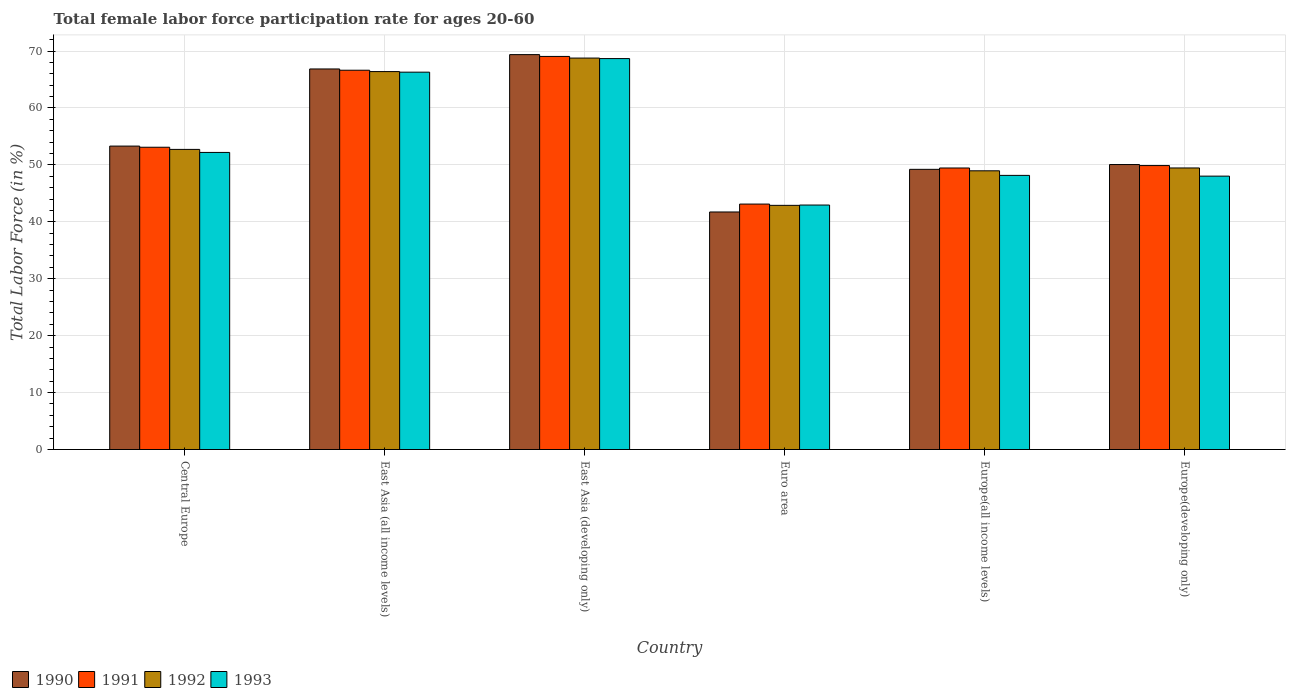How many different coloured bars are there?
Ensure brevity in your answer.  4. How many bars are there on the 2nd tick from the left?
Ensure brevity in your answer.  4. How many bars are there on the 1st tick from the right?
Your answer should be very brief. 4. What is the label of the 6th group of bars from the left?
Provide a short and direct response. Europe(developing only). What is the female labor force participation rate in 1993 in Central Europe?
Your answer should be very brief. 52.19. Across all countries, what is the maximum female labor force participation rate in 1993?
Give a very brief answer. 68.67. Across all countries, what is the minimum female labor force participation rate in 1990?
Give a very brief answer. 41.73. In which country was the female labor force participation rate in 1991 maximum?
Offer a terse response. East Asia (developing only). In which country was the female labor force participation rate in 1993 minimum?
Offer a very short reply. Euro area. What is the total female labor force participation rate in 1990 in the graph?
Ensure brevity in your answer.  330.54. What is the difference between the female labor force participation rate in 1993 in East Asia (all income levels) and that in Europe(all income levels)?
Offer a very short reply. 18.13. What is the difference between the female labor force participation rate in 1990 in East Asia (developing only) and the female labor force participation rate in 1991 in Europe(developing only)?
Your response must be concise. 19.49. What is the average female labor force participation rate in 1991 per country?
Make the answer very short. 55.21. What is the difference between the female labor force participation rate of/in 1992 and female labor force participation rate of/in 1993 in East Asia (all income levels)?
Make the answer very short. 0.1. What is the ratio of the female labor force participation rate in 1993 in East Asia (all income levels) to that in East Asia (developing only)?
Keep it short and to the point. 0.97. Is the female labor force participation rate in 1991 in East Asia (all income levels) less than that in Europe(developing only)?
Your answer should be very brief. No. What is the difference between the highest and the second highest female labor force participation rate in 1991?
Your response must be concise. 13.53. What is the difference between the highest and the lowest female labor force participation rate in 1991?
Make the answer very short. 25.94. Is the sum of the female labor force participation rate in 1992 in East Asia (developing only) and Europe(developing only) greater than the maximum female labor force participation rate in 1993 across all countries?
Your response must be concise. Yes. Is it the case that in every country, the sum of the female labor force participation rate in 1990 and female labor force participation rate in 1991 is greater than the sum of female labor force participation rate in 1992 and female labor force participation rate in 1993?
Offer a terse response. No. How many bars are there?
Provide a succinct answer. 24. Are the values on the major ticks of Y-axis written in scientific E-notation?
Offer a terse response. No. Does the graph contain any zero values?
Your answer should be compact. No. Does the graph contain grids?
Provide a succinct answer. Yes. Where does the legend appear in the graph?
Give a very brief answer. Bottom left. How are the legend labels stacked?
Your response must be concise. Horizontal. What is the title of the graph?
Offer a terse response. Total female labor force participation rate for ages 20-60. What is the label or title of the Y-axis?
Give a very brief answer. Total Labor Force (in %). What is the Total Labor Force (in %) of 1990 in Central Europe?
Provide a succinct answer. 53.31. What is the Total Labor Force (in %) in 1991 in Central Europe?
Give a very brief answer. 53.1. What is the Total Labor Force (in %) of 1992 in Central Europe?
Offer a terse response. 52.72. What is the Total Labor Force (in %) of 1993 in Central Europe?
Offer a very short reply. 52.19. What is the Total Labor Force (in %) in 1990 in East Asia (all income levels)?
Your answer should be compact. 66.85. What is the Total Labor Force (in %) in 1991 in East Asia (all income levels)?
Your answer should be compact. 66.63. What is the Total Labor Force (in %) of 1992 in East Asia (all income levels)?
Ensure brevity in your answer.  66.39. What is the Total Labor Force (in %) in 1993 in East Asia (all income levels)?
Your answer should be compact. 66.29. What is the Total Labor Force (in %) in 1990 in East Asia (developing only)?
Make the answer very short. 69.37. What is the Total Labor Force (in %) of 1991 in East Asia (developing only)?
Offer a terse response. 69.06. What is the Total Labor Force (in %) in 1992 in East Asia (developing only)?
Give a very brief answer. 68.77. What is the Total Labor Force (in %) in 1993 in East Asia (developing only)?
Offer a very short reply. 68.67. What is the Total Labor Force (in %) of 1990 in Euro area?
Give a very brief answer. 41.73. What is the Total Labor Force (in %) of 1991 in Euro area?
Provide a short and direct response. 43.12. What is the Total Labor Force (in %) of 1992 in Euro area?
Ensure brevity in your answer.  42.89. What is the Total Labor Force (in %) in 1993 in Euro area?
Offer a terse response. 42.95. What is the Total Labor Force (in %) in 1990 in Europe(all income levels)?
Provide a succinct answer. 49.22. What is the Total Labor Force (in %) in 1991 in Europe(all income levels)?
Offer a very short reply. 49.46. What is the Total Labor Force (in %) of 1992 in Europe(all income levels)?
Make the answer very short. 48.96. What is the Total Labor Force (in %) in 1993 in Europe(all income levels)?
Offer a very short reply. 48.16. What is the Total Labor Force (in %) in 1990 in Europe(developing only)?
Your response must be concise. 50.06. What is the Total Labor Force (in %) in 1991 in Europe(developing only)?
Provide a short and direct response. 49.88. What is the Total Labor Force (in %) in 1992 in Europe(developing only)?
Ensure brevity in your answer.  49.46. What is the Total Labor Force (in %) in 1993 in Europe(developing only)?
Your answer should be compact. 48.03. Across all countries, what is the maximum Total Labor Force (in %) in 1990?
Keep it short and to the point. 69.37. Across all countries, what is the maximum Total Labor Force (in %) of 1991?
Your answer should be compact. 69.06. Across all countries, what is the maximum Total Labor Force (in %) of 1992?
Provide a short and direct response. 68.77. Across all countries, what is the maximum Total Labor Force (in %) of 1993?
Offer a very short reply. 68.67. Across all countries, what is the minimum Total Labor Force (in %) of 1990?
Your answer should be compact. 41.73. Across all countries, what is the minimum Total Labor Force (in %) of 1991?
Your answer should be compact. 43.12. Across all countries, what is the minimum Total Labor Force (in %) in 1992?
Offer a terse response. 42.89. Across all countries, what is the minimum Total Labor Force (in %) of 1993?
Keep it short and to the point. 42.95. What is the total Total Labor Force (in %) of 1990 in the graph?
Keep it short and to the point. 330.54. What is the total Total Labor Force (in %) of 1991 in the graph?
Make the answer very short. 331.24. What is the total Total Labor Force (in %) in 1992 in the graph?
Keep it short and to the point. 329.2. What is the total Total Labor Force (in %) of 1993 in the graph?
Make the answer very short. 326.28. What is the difference between the Total Labor Force (in %) in 1990 in Central Europe and that in East Asia (all income levels)?
Offer a terse response. -13.55. What is the difference between the Total Labor Force (in %) in 1991 in Central Europe and that in East Asia (all income levels)?
Give a very brief answer. -13.53. What is the difference between the Total Labor Force (in %) of 1992 in Central Europe and that in East Asia (all income levels)?
Provide a succinct answer. -13.67. What is the difference between the Total Labor Force (in %) in 1993 in Central Europe and that in East Asia (all income levels)?
Give a very brief answer. -14.1. What is the difference between the Total Labor Force (in %) of 1990 in Central Europe and that in East Asia (developing only)?
Give a very brief answer. -16.07. What is the difference between the Total Labor Force (in %) of 1991 in Central Europe and that in East Asia (developing only)?
Offer a very short reply. -15.95. What is the difference between the Total Labor Force (in %) of 1992 in Central Europe and that in East Asia (developing only)?
Keep it short and to the point. -16.04. What is the difference between the Total Labor Force (in %) in 1993 in Central Europe and that in East Asia (developing only)?
Your answer should be very brief. -16.49. What is the difference between the Total Labor Force (in %) in 1990 in Central Europe and that in Euro area?
Offer a terse response. 11.58. What is the difference between the Total Labor Force (in %) in 1991 in Central Europe and that in Euro area?
Make the answer very short. 9.98. What is the difference between the Total Labor Force (in %) in 1992 in Central Europe and that in Euro area?
Your answer should be compact. 9.83. What is the difference between the Total Labor Force (in %) in 1993 in Central Europe and that in Euro area?
Your answer should be compact. 9.24. What is the difference between the Total Labor Force (in %) of 1990 in Central Europe and that in Europe(all income levels)?
Offer a terse response. 4.08. What is the difference between the Total Labor Force (in %) of 1991 in Central Europe and that in Europe(all income levels)?
Provide a short and direct response. 3.64. What is the difference between the Total Labor Force (in %) of 1992 in Central Europe and that in Europe(all income levels)?
Your response must be concise. 3.76. What is the difference between the Total Labor Force (in %) of 1993 in Central Europe and that in Europe(all income levels)?
Your response must be concise. 4.03. What is the difference between the Total Labor Force (in %) of 1990 in Central Europe and that in Europe(developing only)?
Provide a succinct answer. 3.24. What is the difference between the Total Labor Force (in %) of 1991 in Central Europe and that in Europe(developing only)?
Your response must be concise. 3.22. What is the difference between the Total Labor Force (in %) in 1992 in Central Europe and that in Europe(developing only)?
Your answer should be compact. 3.26. What is the difference between the Total Labor Force (in %) in 1993 in Central Europe and that in Europe(developing only)?
Give a very brief answer. 4.16. What is the difference between the Total Labor Force (in %) of 1990 in East Asia (all income levels) and that in East Asia (developing only)?
Offer a very short reply. -2.52. What is the difference between the Total Labor Force (in %) in 1991 in East Asia (all income levels) and that in East Asia (developing only)?
Provide a short and direct response. -2.43. What is the difference between the Total Labor Force (in %) of 1992 in East Asia (all income levels) and that in East Asia (developing only)?
Your answer should be very brief. -2.37. What is the difference between the Total Labor Force (in %) of 1993 in East Asia (all income levels) and that in East Asia (developing only)?
Offer a terse response. -2.38. What is the difference between the Total Labor Force (in %) in 1990 in East Asia (all income levels) and that in Euro area?
Offer a terse response. 25.12. What is the difference between the Total Labor Force (in %) of 1991 in East Asia (all income levels) and that in Euro area?
Give a very brief answer. 23.51. What is the difference between the Total Labor Force (in %) in 1992 in East Asia (all income levels) and that in Euro area?
Give a very brief answer. 23.5. What is the difference between the Total Labor Force (in %) of 1993 in East Asia (all income levels) and that in Euro area?
Keep it short and to the point. 23.34. What is the difference between the Total Labor Force (in %) in 1990 in East Asia (all income levels) and that in Europe(all income levels)?
Offer a terse response. 17.63. What is the difference between the Total Labor Force (in %) of 1991 in East Asia (all income levels) and that in Europe(all income levels)?
Your response must be concise. 17.17. What is the difference between the Total Labor Force (in %) of 1992 in East Asia (all income levels) and that in Europe(all income levels)?
Your answer should be very brief. 17.43. What is the difference between the Total Labor Force (in %) of 1993 in East Asia (all income levels) and that in Europe(all income levels)?
Your answer should be very brief. 18.13. What is the difference between the Total Labor Force (in %) in 1990 in East Asia (all income levels) and that in Europe(developing only)?
Provide a short and direct response. 16.79. What is the difference between the Total Labor Force (in %) of 1991 in East Asia (all income levels) and that in Europe(developing only)?
Your answer should be compact. 16.75. What is the difference between the Total Labor Force (in %) of 1992 in East Asia (all income levels) and that in Europe(developing only)?
Make the answer very short. 16.93. What is the difference between the Total Labor Force (in %) of 1993 in East Asia (all income levels) and that in Europe(developing only)?
Your answer should be very brief. 18.26. What is the difference between the Total Labor Force (in %) in 1990 in East Asia (developing only) and that in Euro area?
Give a very brief answer. 27.64. What is the difference between the Total Labor Force (in %) of 1991 in East Asia (developing only) and that in Euro area?
Offer a terse response. 25.94. What is the difference between the Total Labor Force (in %) of 1992 in East Asia (developing only) and that in Euro area?
Your answer should be compact. 25.87. What is the difference between the Total Labor Force (in %) in 1993 in East Asia (developing only) and that in Euro area?
Keep it short and to the point. 25.73. What is the difference between the Total Labor Force (in %) of 1990 in East Asia (developing only) and that in Europe(all income levels)?
Offer a terse response. 20.15. What is the difference between the Total Labor Force (in %) in 1991 in East Asia (developing only) and that in Europe(all income levels)?
Provide a succinct answer. 19.6. What is the difference between the Total Labor Force (in %) of 1992 in East Asia (developing only) and that in Europe(all income levels)?
Your response must be concise. 19.81. What is the difference between the Total Labor Force (in %) of 1993 in East Asia (developing only) and that in Europe(all income levels)?
Your answer should be very brief. 20.52. What is the difference between the Total Labor Force (in %) in 1990 in East Asia (developing only) and that in Europe(developing only)?
Your answer should be compact. 19.31. What is the difference between the Total Labor Force (in %) of 1991 in East Asia (developing only) and that in Europe(developing only)?
Your answer should be compact. 19.17. What is the difference between the Total Labor Force (in %) of 1992 in East Asia (developing only) and that in Europe(developing only)?
Keep it short and to the point. 19.3. What is the difference between the Total Labor Force (in %) in 1993 in East Asia (developing only) and that in Europe(developing only)?
Your response must be concise. 20.65. What is the difference between the Total Labor Force (in %) in 1990 in Euro area and that in Europe(all income levels)?
Your answer should be very brief. -7.49. What is the difference between the Total Labor Force (in %) of 1991 in Euro area and that in Europe(all income levels)?
Provide a succinct answer. -6.34. What is the difference between the Total Labor Force (in %) in 1992 in Euro area and that in Europe(all income levels)?
Provide a succinct answer. -6.07. What is the difference between the Total Labor Force (in %) of 1993 in Euro area and that in Europe(all income levels)?
Your answer should be compact. -5.21. What is the difference between the Total Labor Force (in %) in 1990 in Euro area and that in Europe(developing only)?
Your answer should be compact. -8.33. What is the difference between the Total Labor Force (in %) of 1991 in Euro area and that in Europe(developing only)?
Keep it short and to the point. -6.76. What is the difference between the Total Labor Force (in %) of 1992 in Euro area and that in Europe(developing only)?
Ensure brevity in your answer.  -6.57. What is the difference between the Total Labor Force (in %) of 1993 in Euro area and that in Europe(developing only)?
Your answer should be very brief. -5.08. What is the difference between the Total Labor Force (in %) of 1990 in Europe(all income levels) and that in Europe(developing only)?
Keep it short and to the point. -0.84. What is the difference between the Total Labor Force (in %) of 1991 in Europe(all income levels) and that in Europe(developing only)?
Provide a succinct answer. -0.43. What is the difference between the Total Labor Force (in %) of 1992 in Europe(all income levels) and that in Europe(developing only)?
Provide a succinct answer. -0.5. What is the difference between the Total Labor Force (in %) of 1993 in Europe(all income levels) and that in Europe(developing only)?
Provide a succinct answer. 0.13. What is the difference between the Total Labor Force (in %) in 1990 in Central Europe and the Total Labor Force (in %) in 1991 in East Asia (all income levels)?
Give a very brief answer. -13.32. What is the difference between the Total Labor Force (in %) in 1990 in Central Europe and the Total Labor Force (in %) in 1992 in East Asia (all income levels)?
Your answer should be very brief. -13.09. What is the difference between the Total Labor Force (in %) in 1990 in Central Europe and the Total Labor Force (in %) in 1993 in East Asia (all income levels)?
Offer a terse response. -12.99. What is the difference between the Total Labor Force (in %) in 1991 in Central Europe and the Total Labor Force (in %) in 1992 in East Asia (all income levels)?
Give a very brief answer. -13.29. What is the difference between the Total Labor Force (in %) of 1991 in Central Europe and the Total Labor Force (in %) of 1993 in East Asia (all income levels)?
Your answer should be very brief. -13.19. What is the difference between the Total Labor Force (in %) of 1992 in Central Europe and the Total Labor Force (in %) of 1993 in East Asia (all income levels)?
Ensure brevity in your answer.  -13.57. What is the difference between the Total Labor Force (in %) of 1990 in Central Europe and the Total Labor Force (in %) of 1991 in East Asia (developing only)?
Provide a succinct answer. -15.75. What is the difference between the Total Labor Force (in %) of 1990 in Central Europe and the Total Labor Force (in %) of 1992 in East Asia (developing only)?
Your answer should be compact. -15.46. What is the difference between the Total Labor Force (in %) in 1990 in Central Europe and the Total Labor Force (in %) in 1993 in East Asia (developing only)?
Provide a short and direct response. -15.37. What is the difference between the Total Labor Force (in %) in 1991 in Central Europe and the Total Labor Force (in %) in 1992 in East Asia (developing only)?
Make the answer very short. -15.67. What is the difference between the Total Labor Force (in %) of 1991 in Central Europe and the Total Labor Force (in %) of 1993 in East Asia (developing only)?
Offer a very short reply. -15.57. What is the difference between the Total Labor Force (in %) of 1992 in Central Europe and the Total Labor Force (in %) of 1993 in East Asia (developing only)?
Provide a succinct answer. -15.95. What is the difference between the Total Labor Force (in %) in 1990 in Central Europe and the Total Labor Force (in %) in 1991 in Euro area?
Keep it short and to the point. 10.19. What is the difference between the Total Labor Force (in %) of 1990 in Central Europe and the Total Labor Force (in %) of 1992 in Euro area?
Your answer should be compact. 10.41. What is the difference between the Total Labor Force (in %) of 1990 in Central Europe and the Total Labor Force (in %) of 1993 in Euro area?
Your answer should be compact. 10.36. What is the difference between the Total Labor Force (in %) in 1991 in Central Europe and the Total Labor Force (in %) in 1992 in Euro area?
Provide a succinct answer. 10.21. What is the difference between the Total Labor Force (in %) of 1991 in Central Europe and the Total Labor Force (in %) of 1993 in Euro area?
Your answer should be compact. 10.15. What is the difference between the Total Labor Force (in %) of 1992 in Central Europe and the Total Labor Force (in %) of 1993 in Euro area?
Offer a very short reply. 9.78. What is the difference between the Total Labor Force (in %) of 1990 in Central Europe and the Total Labor Force (in %) of 1991 in Europe(all income levels)?
Make the answer very short. 3.85. What is the difference between the Total Labor Force (in %) in 1990 in Central Europe and the Total Labor Force (in %) in 1992 in Europe(all income levels)?
Provide a succinct answer. 4.34. What is the difference between the Total Labor Force (in %) in 1990 in Central Europe and the Total Labor Force (in %) in 1993 in Europe(all income levels)?
Keep it short and to the point. 5.15. What is the difference between the Total Labor Force (in %) of 1991 in Central Europe and the Total Labor Force (in %) of 1992 in Europe(all income levels)?
Keep it short and to the point. 4.14. What is the difference between the Total Labor Force (in %) of 1991 in Central Europe and the Total Labor Force (in %) of 1993 in Europe(all income levels)?
Provide a succinct answer. 4.94. What is the difference between the Total Labor Force (in %) of 1992 in Central Europe and the Total Labor Force (in %) of 1993 in Europe(all income levels)?
Offer a very short reply. 4.56. What is the difference between the Total Labor Force (in %) in 1990 in Central Europe and the Total Labor Force (in %) in 1991 in Europe(developing only)?
Make the answer very short. 3.42. What is the difference between the Total Labor Force (in %) of 1990 in Central Europe and the Total Labor Force (in %) of 1992 in Europe(developing only)?
Offer a terse response. 3.84. What is the difference between the Total Labor Force (in %) of 1990 in Central Europe and the Total Labor Force (in %) of 1993 in Europe(developing only)?
Offer a very short reply. 5.28. What is the difference between the Total Labor Force (in %) in 1991 in Central Europe and the Total Labor Force (in %) in 1992 in Europe(developing only)?
Your response must be concise. 3.64. What is the difference between the Total Labor Force (in %) of 1991 in Central Europe and the Total Labor Force (in %) of 1993 in Europe(developing only)?
Offer a very short reply. 5.07. What is the difference between the Total Labor Force (in %) in 1992 in Central Europe and the Total Labor Force (in %) in 1993 in Europe(developing only)?
Your answer should be compact. 4.7. What is the difference between the Total Labor Force (in %) in 1990 in East Asia (all income levels) and the Total Labor Force (in %) in 1991 in East Asia (developing only)?
Your response must be concise. -2.2. What is the difference between the Total Labor Force (in %) in 1990 in East Asia (all income levels) and the Total Labor Force (in %) in 1992 in East Asia (developing only)?
Keep it short and to the point. -1.91. What is the difference between the Total Labor Force (in %) of 1990 in East Asia (all income levels) and the Total Labor Force (in %) of 1993 in East Asia (developing only)?
Keep it short and to the point. -1.82. What is the difference between the Total Labor Force (in %) of 1991 in East Asia (all income levels) and the Total Labor Force (in %) of 1992 in East Asia (developing only)?
Ensure brevity in your answer.  -2.14. What is the difference between the Total Labor Force (in %) of 1991 in East Asia (all income levels) and the Total Labor Force (in %) of 1993 in East Asia (developing only)?
Offer a very short reply. -2.04. What is the difference between the Total Labor Force (in %) in 1992 in East Asia (all income levels) and the Total Labor Force (in %) in 1993 in East Asia (developing only)?
Your answer should be very brief. -2.28. What is the difference between the Total Labor Force (in %) of 1990 in East Asia (all income levels) and the Total Labor Force (in %) of 1991 in Euro area?
Keep it short and to the point. 23.74. What is the difference between the Total Labor Force (in %) of 1990 in East Asia (all income levels) and the Total Labor Force (in %) of 1992 in Euro area?
Provide a succinct answer. 23.96. What is the difference between the Total Labor Force (in %) of 1990 in East Asia (all income levels) and the Total Labor Force (in %) of 1993 in Euro area?
Offer a terse response. 23.91. What is the difference between the Total Labor Force (in %) of 1991 in East Asia (all income levels) and the Total Labor Force (in %) of 1992 in Euro area?
Give a very brief answer. 23.74. What is the difference between the Total Labor Force (in %) of 1991 in East Asia (all income levels) and the Total Labor Force (in %) of 1993 in Euro area?
Ensure brevity in your answer.  23.68. What is the difference between the Total Labor Force (in %) in 1992 in East Asia (all income levels) and the Total Labor Force (in %) in 1993 in Euro area?
Ensure brevity in your answer.  23.45. What is the difference between the Total Labor Force (in %) in 1990 in East Asia (all income levels) and the Total Labor Force (in %) in 1991 in Europe(all income levels)?
Offer a terse response. 17.4. What is the difference between the Total Labor Force (in %) of 1990 in East Asia (all income levels) and the Total Labor Force (in %) of 1992 in Europe(all income levels)?
Provide a succinct answer. 17.89. What is the difference between the Total Labor Force (in %) of 1990 in East Asia (all income levels) and the Total Labor Force (in %) of 1993 in Europe(all income levels)?
Your response must be concise. 18.7. What is the difference between the Total Labor Force (in %) of 1991 in East Asia (all income levels) and the Total Labor Force (in %) of 1992 in Europe(all income levels)?
Ensure brevity in your answer.  17.67. What is the difference between the Total Labor Force (in %) in 1991 in East Asia (all income levels) and the Total Labor Force (in %) in 1993 in Europe(all income levels)?
Keep it short and to the point. 18.47. What is the difference between the Total Labor Force (in %) in 1992 in East Asia (all income levels) and the Total Labor Force (in %) in 1993 in Europe(all income levels)?
Provide a succinct answer. 18.24. What is the difference between the Total Labor Force (in %) in 1990 in East Asia (all income levels) and the Total Labor Force (in %) in 1991 in Europe(developing only)?
Your answer should be compact. 16.97. What is the difference between the Total Labor Force (in %) of 1990 in East Asia (all income levels) and the Total Labor Force (in %) of 1992 in Europe(developing only)?
Offer a very short reply. 17.39. What is the difference between the Total Labor Force (in %) of 1990 in East Asia (all income levels) and the Total Labor Force (in %) of 1993 in Europe(developing only)?
Offer a very short reply. 18.83. What is the difference between the Total Labor Force (in %) of 1991 in East Asia (all income levels) and the Total Labor Force (in %) of 1992 in Europe(developing only)?
Ensure brevity in your answer.  17.17. What is the difference between the Total Labor Force (in %) of 1991 in East Asia (all income levels) and the Total Labor Force (in %) of 1993 in Europe(developing only)?
Provide a short and direct response. 18.6. What is the difference between the Total Labor Force (in %) in 1992 in East Asia (all income levels) and the Total Labor Force (in %) in 1993 in Europe(developing only)?
Provide a succinct answer. 18.37. What is the difference between the Total Labor Force (in %) of 1990 in East Asia (developing only) and the Total Labor Force (in %) of 1991 in Euro area?
Offer a very short reply. 26.25. What is the difference between the Total Labor Force (in %) of 1990 in East Asia (developing only) and the Total Labor Force (in %) of 1992 in Euro area?
Keep it short and to the point. 26.48. What is the difference between the Total Labor Force (in %) in 1990 in East Asia (developing only) and the Total Labor Force (in %) in 1993 in Euro area?
Give a very brief answer. 26.43. What is the difference between the Total Labor Force (in %) in 1991 in East Asia (developing only) and the Total Labor Force (in %) in 1992 in Euro area?
Your answer should be very brief. 26.16. What is the difference between the Total Labor Force (in %) of 1991 in East Asia (developing only) and the Total Labor Force (in %) of 1993 in Euro area?
Ensure brevity in your answer.  26.11. What is the difference between the Total Labor Force (in %) in 1992 in East Asia (developing only) and the Total Labor Force (in %) in 1993 in Euro area?
Give a very brief answer. 25.82. What is the difference between the Total Labor Force (in %) of 1990 in East Asia (developing only) and the Total Labor Force (in %) of 1991 in Europe(all income levels)?
Offer a very short reply. 19.92. What is the difference between the Total Labor Force (in %) of 1990 in East Asia (developing only) and the Total Labor Force (in %) of 1992 in Europe(all income levels)?
Your answer should be compact. 20.41. What is the difference between the Total Labor Force (in %) of 1990 in East Asia (developing only) and the Total Labor Force (in %) of 1993 in Europe(all income levels)?
Your answer should be compact. 21.22. What is the difference between the Total Labor Force (in %) in 1991 in East Asia (developing only) and the Total Labor Force (in %) in 1992 in Europe(all income levels)?
Offer a very short reply. 20.09. What is the difference between the Total Labor Force (in %) in 1991 in East Asia (developing only) and the Total Labor Force (in %) in 1993 in Europe(all income levels)?
Ensure brevity in your answer.  20.9. What is the difference between the Total Labor Force (in %) of 1992 in East Asia (developing only) and the Total Labor Force (in %) of 1993 in Europe(all income levels)?
Make the answer very short. 20.61. What is the difference between the Total Labor Force (in %) in 1990 in East Asia (developing only) and the Total Labor Force (in %) in 1991 in Europe(developing only)?
Ensure brevity in your answer.  19.49. What is the difference between the Total Labor Force (in %) in 1990 in East Asia (developing only) and the Total Labor Force (in %) in 1992 in Europe(developing only)?
Give a very brief answer. 19.91. What is the difference between the Total Labor Force (in %) of 1990 in East Asia (developing only) and the Total Labor Force (in %) of 1993 in Europe(developing only)?
Give a very brief answer. 21.35. What is the difference between the Total Labor Force (in %) in 1991 in East Asia (developing only) and the Total Labor Force (in %) in 1992 in Europe(developing only)?
Keep it short and to the point. 19.59. What is the difference between the Total Labor Force (in %) in 1991 in East Asia (developing only) and the Total Labor Force (in %) in 1993 in Europe(developing only)?
Provide a succinct answer. 21.03. What is the difference between the Total Labor Force (in %) in 1992 in East Asia (developing only) and the Total Labor Force (in %) in 1993 in Europe(developing only)?
Offer a very short reply. 20.74. What is the difference between the Total Labor Force (in %) in 1990 in Euro area and the Total Labor Force (in %) in 1991 in Europe(all income levels)?
Ensure brevity in your answer.  -7.73. What is the difference between the Total Labor Force (in %) in 1990 in Euro area and the Total Labor Force (in %) in 1992 in Europe(all income levels)?
Your answer should be very brief. -7.23. What is the difference between the Total Labor Force (in %) of 1990 in Euro area and the Total Labor Force (in %) of 1993 in Europe(all income levels)?
Offer a terse response. -6.43. What is the difference between the Total Labor Force (in %) of 1991 in Euro area and the Total Labor Force (in %) of 1992 in Europe(all income levels)?
Offer a very short reply. -5.84. What is the difference between the Total Labor Force (in %) in 1991 in Euro area and the Total Labor Force (in %) in 1993 in Europe(all income levels)?
Your answer should be very brief. -5.04. What is the difference between the Total Labor Force (in %) in 1992 in Euro area and the Total Labor Force (in %) in 1993 in Europe(all income levels)?
Provide a succinct answer. -5.26. What is the difference between the Total Labor Force (in %) in 1990 in Euro area and the Total Labor Force (in %) in 1991 in Europe(developing only)?
Provide a succinct answer. -8.15. What is the difference between the Total Labor Force (in %) in 1990 in Euro area and the Total Labor Force (in %) in 1992 in Europe(developing only)?
Provide a succinct answer. -7.73. What is the difference between the Total Labor Force (in %) in 1990 in Euro area and the Total Labor Force (in %) in 1993 in Europe(developing only)?
Ensure brevity in your answer.  -6.3. What is the difference between the Total Labor Force (in %) of 1991 in Euro area and the Total Labor Force (in %) of 1992 in Europe(developing only)?
Your response must be concise. -6.34. What is the difference between the Total Labor Force (in %) of 1991 in Euro area and the Total Labor Force (in %) of 1993 in Europe(developing only)?
Offer a terse response. -4.91. What is the difference between the Total Labor Force (in %) in 1992 in Euro area and the Total Labor Force (in %) in 1993 in Europe(developing only)?
Keep it short and to the point. -5.13. What is the difference between the Total Labor Force (in %) in 1990 in Europe(all income levels) and the Total Labor Force (in %) in 1991 in Europe(developing only)?
Offer a terse response. -0.66. What is the difference between the Total Labor Force (in %) of 1990 in Europe(all income levels) and the Total Labor Force (in %) of 1992 in Europe(developing only)?
Provide a succinct answer. -0.24. What is the difference between the Total Labor Force (in %) in 1990 in Europe(all income levels) and the Total Labor Force (in %) in 1993 in Europe(developing only)?
Your answer should be compact. 1.19. What is the difference between the Total Labor Force (in %) of 1991 in Europe(all income levels) and the Total Labor Force (in %) of 1992 in Europe(developing only)?
Provide a short and direct response. -0.01. What is the difference between the Total Labor Force (in %) of 1991 in Europe(all income levels) and the Total Labor Force (in %) of 1993 in Europe(developing only)?
Offer a very short reply. 1.43. What is the difference between the Total Labor Force (in %) in 1992 in Europe(all income levels) and the Total Labor Force (in %) in 1993 in Europe(developing only)?
Ensure brevity in your answer.  0.94. What is the average Total Labor Force (in %) of 1990 per country?
Offer a terse response. 55.09. What is the average Total Labor Force (in %) in 1991 per country?
Offer a very short reply. 55.21. What is the average Total Labor Force (in %) in 1992 per country?
Offer a terse response. 54.87. What is the average Total Labor Force (in %) in 1993 per country?
Keep it short and to the point. 54.38. What is the difference between the Total Labor Force (in %) of 1990 and Total Labor Force (in %) of 1991 in Central Europe?
Provide a short and direct response. 0.2. What is the difference between the Total Labor Force (in %) in 1990 and Total Labor Force (in %) in 1992 in Central Europe?
Provide a short and direct response. 0.58. What is the difference between the Total Labor Force (in %) in 1990 and Total Labor Force (in %) in 1993 in Central Europe?
Your answer should be compact. 1.12. What is the difference between the Total Labor Force (in %) of 1991 and Total Labor Force (in %) of 1992 in Central Europe?
Your response must be concise. 0.38. What is the difference between the Total Labor Force (in %) of 1991 and Total Labor Force (in %) of 1993 in Central Europe?
Give a very brief answer. 0.91. What is the difference between the Total Labor Force (in %) in 1992 and Total Labor Force (in %) in 1993 in Central Europe?
Ensure brevity in your answer.  0.53. What is the difference between the Total Labor Force (in %) in 1990 and Total Labor Force (in %) in 1991 in East Asia (all income levels)?
Provide a succinct answer. 0.22. What is the difference between the Total Labor Force (in %) in 1990 and Total Labor Force (in %) in 1992 in East Asia (all income levels)?
Your response must be concise. 0.46. What is the difference between the Total Labor Force (in %) of 1990 and Total Labor Force (in %) of 1993 in East Asia (all income levels)?
Offer a terse response. 0.56. What is the difference between the Total Labor Force (in %) in 1991 and Total Labor Force (in %) in 1992 in East Asia (all income levels)?
Offer a very short reply. 0.24. What is the difference between the Total Labor Force (in %) of 1991 and Total Labor Force (in %) of 1993 in East Asia (all income levels)?
Ensure brevity in your answer.  0.34. What is the difference between the Total Labor Force (in %) of 1992 and Total Labor Force (in %) of 1993 in East Asia (all income levels)?
Your answer should be compact. 0.1. What is the difference between the Total Labor Force (in %) in 1990 and Total Labor Force (in %) in 1991 in East Asia (developing only)?
Your answer should be compact. 0.32. What is the difference between the Total Labor Force (in %) of 1990 and Total Labor Force (in %) of 1992 in East Asia (developing only)?
Your response must be concise. 0.61. What is the difference between the Total Labor Force (in %) in 1990 and Total Labor Force (in %) in 1993 in East Asia (developing only)?
Your response must be concise. 0.7. What is the difference between the Total Labor Force (in %) in 1991 and Total Labor Force (in %) in 1992 in East Asia (developing only)?
Give a very brief answer. 0.29. What is the difference between the Total Labor Force (in %) of 1991 and Total Labor Force (in %) of 1993 in East Asia (developing only)?
Provide a succinct answer. 0.38. What is the difference between the Total Labor Force (in %) in 1992 and Total Labor Force (in %) in 1993 in East Asia (developing only)?
Keep it short and to the point. 0.09. What is the difference between the Total Labor Force (in %) in 1990 and Total Labor Force (in %) in 1991 in Euro area?
Your answer should be compact. -1.39. What is the difference between the Total Labor Force (in %) in 1990 and Total Labor Force (in %) in 1992 in Euro area?
Offer a very short reply. -1.16. What is the difference between the Total Labor Force (in %) of 1990 and Total Labor Force (in %) of 1993 in Euro area?
Keep it short and to the point. -1.22. What is the difference between the Total Labor Force (in %) of 1991 and Total Labor Force (in %) of 1992 in Euro area?
Your response must be concise. 0.22. What is the difference between the Total Labor Force (in %) in 1991 and Total Labor Force (in %) in 1993 in Euro area?
Your answer should be compact. 0.17. What is the difference between the Total Labor Force (in %) of 1992 and Total Labor Force (in %) of 1993 in Euro area?
Provide a short and direct response. -0.05. What is the difference between the Total Labor Force (in %) in 1990 and Total Labor Force (in %) in 1991 in Europe(all income levels)?
Make the answer very short. -0.24. What is the difference between the Total Labor Force (in %) in 1990 and Total Labor Force (in %) in 1992 in Europe(all income levels)?
Offer a very short reply. 0.26. What is the difference between the Total Labor Force (in %) in 1990 and Total Labor Force (in %) in 1993 in Europe(all income levels)?
Provide a succinct answer. 1.06. What is the difference between the Total Labor Force (in %) in 1991 and Total Labor Force (in %) in 1992 in Europe(all income levels)?
Ensure brevity in your answer.  0.49. What is the difference between the Total Labor Force (in %) in 1991 and Total Labor Force (in %) in 1993 in Europe(all income levels)?
Provide a short and direct response. 1.3. What is the difference between the Total Labor Force (in %) of 1992 and Total Labor Force (in %) of 1993 in Europe(all income levels)?
Provide a succinct answer. 0.8. What is the difference between the Total Labor Force (in %) in 1990 and Total Labor Force (in %) in 1991 in Europe(developing only)?
Your response must be concise. 0.18. What is the difference between the Total Labor Force (in %) in 1990 and Total Labor Force (in %) in 1992 in Europe(developing only)?
Your answer should be compact. 0.6. What is the difference between the Total Labor Force (in %) in 1990 and Total Labor Force (in %) in 1993 in Europe(developing only)?
Offer a terse response. 2.04. What is the difference between the Total Labor Force (in %) of 1991 and Total Labor Force (in %) of 1992 in Europe(developing only)?
Give a very brief answer. 0.42. What is the difference between the Total Labor Force (in %) in 1991 and Total Labor Force (in %) in 1993 in Europe(developing only)?
Provide a short and direct response. 1.86. What is the difference between the Total Labor Force (in %) in 1992 and Total Labor Force (in %) in 1993 in Europe(developing only)?
Provide a succinct answer. 1.44. What is the ratio of the Total Labor Force (in %) in 1990 in Central Europe to that in East Asia (all income levels)?
Your answer should be very brief. 0.8. What is the ratio of the Total Labor Force (in %) in 1991 in Central Europe to that in East Asia (all income levels)?
Provide a succinct answer. 0.8. What is the ratio of the Total Labor Force (in %) in 1992 in Central Europe to that in East Asia (all income levels)?
Offer a terse response. 0.79. What is the ratio of the Total Labor Force (in %) in 1993 in Central Europe to that in East Asia (all income levels)?
Provide a short and direct response. 0.79. What is the ratio of the Total Labor Force (in %) of 1990 in Central Europe to that in East Asia (developing only)?
Keep it short and to the point. 0.77. What is the ratio of the Total Labor Force (in %) in 1991 in Central Europe to that in East Asia (developing only)?
Keep it short and to the point. 0.77. What is the ratio of the Total Labor Force (in %) in 1992 in Central Europe to that in East Asia (developing only)?
Give a very brief answer. 0.77. What is the ratio of the Total Labor Force (in %) in 1993 in Central Europe to that in East Asia (developing only)?
Provide a short and direct response. 0.76. What is the ratio of the Total Labor Force (in %) in 1990 in Central Europe to that in Euro area?
Offer a terse response. 1.28. What is the ratio of the Total Labor Force (in %) in 1991 in Central Europe to that in Euro area?
Your response must be concise. 1.23. What is the ratio of the Total Labor Force (in %) in 1992 in Central Europe to that in Euro area?
Give a very brief answer. 1.23. What is the ratio of the Total Labor Force (in %) of 1993 in Central Europe to that in Euro area?
Your answer should be compact. 1.22. What is the ratio of the Total Labor Force (in %) in 1990 in Central Europe to that in Europe(all income levels)?
Your response must be concise. 1.08. What is the ratio of the Total Labor Force (in %) in 1991 in Central Europe to that in Europe(all income levels)?
Keep it short and to the point. 1.07. What is the ratio of the Total Labor Force (in %) in 1992 in Central Europe to that in Europe(all income levels)?
Your answer should be compact. 1.08. What is the ratio of the Total Labor Force (in %) of 1993 in Central Europe to that in Europe(all income levels)?
Ensure brevity in your answer.  1.08. What is the ratio of the Total Labor Force (in %) in 1990 in Central Europe to that in Europe(developing only)?
Give a very brief answer. 1.06. What is the ratio of the Total Labor Force (in %) in 1991 in Central Europe to that in Europe(developing only)?
Offer a terse response. 1.06. What is the ratio of the Total Labor Force (in %) in 1992 in Central Europe to that in Europe(developing only)?
Provide a succinct answer. 1.07. What is the ratio of the Total Labor Force (in %) of 1993 in Central Europe to that in Europe(developing only)?
Ensure brevity in your answer.  1.09. What is the ratio of the Total Labor Force (in %) in 1990 in East Asia (all income levels) to that in East Asia (developing only)?
Your response must be concise. 0.96. What is the ratio of the Total Labor Force (in %) in 1991 in East Asia (all income levels) to that in East Asia (developing only)?
Offer a terse response. 0.96. What is the ratio of the Total Labor Force (in %) in 1992 in East Asia (all income levels) to that in East Asia (developing only)?
Offer a terse response. 0.97. What is the ratio of the Total Labor Force (in %) in 1993 in East Asia (all income levels) to that in East Asia (developing only)?
Provide a short and direct response. 0.97. What is the ratio of the Total Labor Force (in %) of 1990 in East Asia (all income levels) to that in Euro area?
Provide a succinct answer. 1.6. What is the ratio of the Total Labor Force (in %) of 1991 in East Asia (all income levels) to that in Euro area?
Offer a very short reply. 1.55. What is the ratio of the Total Labor Force (in %) of 1992 in East Asia (all income levels) to that in Euro area?
Provide a succinct answer. 1.55. What is the ratio of the Total Labor Force (in %) in 1993 in East Asia (all income levels) to that in Euro area?
Your answer should be very brief. 1.54. What is the ratio of the Total Labor Force (in %) of 1990 in East Asia (all income levels) to that in Europe(all income levels)?
Your response must be concise. 1.36. What is the ratio of the Total Labor Force (in %) in 1991 in East Asia (all income levels) to that in Europe(all income levels)?
Offer a very short reply. 1.35. What is the ratio of the Total Labor Force (in %) in 1992 in East Asia (all income levels) to that in Europe(all income levels)?
Your answer should be compact. 1.36. What is the ratio of the Total Labor Force (in %) in 1993 in East Asia (all income levels) to that in Europe(all income levels)?
Keep it short and to the point. 1.38. What is the ratio of the Total Labor Force (in %) in 1990 in East Asia (all income levels) to that in Europe(developing only)?
Offer a terse response. 1.34. What is the ratio of the Total Labor Force (in %) of 1991 in East Asia (all income levels) to that in Europe(developing only)?
Your answer should be very brief. 1.34. What is the ratio of the Total Labor Force (in %) of 1992 in East Asia (all income levels) to that in Europe(developing only)?
Ensure brevity in your answer.  1.34. What is the ratio of the Total Labor Force (in %) of 1993 in East Asia (all income levels) to that in Europe(developing only)?
Give a very brief answer. 1.38. What is the ratio of the Total Labor Force (in %) of 1990 in East Asia (developing only) to that in Euro area?
Your response must be concise. 1.66. What is the ratio of the Total Labor Force (in %) in 1991 in East Asia (developing only) to that in Euro area?
Offer a terse response. 1.6. What is the ratio of the Total Labor Force (in %) in 1992 in East Asia (developing only) to that in Euro area?
Make the answer very short. 1.6. What is the ratio of the Total Labor Force (in %) of 1993 in East Asia (developing only) to that in Euro area?
Give a very brief answer. 1.6. What is the ratio of the Total Labor Force (in %) of 1990 in East Asia (developing only) to that in Europe(all income levels)?
Keep it short and to the point. 1.41. What is the ratio of the Total Labor Force (in %) of 1991 in East Asia (developing only) to that in Europe(all income levels)?
Offer a very short reply. 1.4. What is the ratio of the Total Labor Force (in %) in 1992 in East Asia (developing only) to that in Europe(all income levels)?
Offer a terse response. 1.4. What is the ratio of the Total Labor Force (in %) of 1993 in East Asia (developing only) to that in Europe(all income levels)?
Your response must be concise. 1.43. What is the ratio of the Total Labor Force (in %) in 1990 in East Asia (developing only) to that in Europe(developing only)?
Provide a short and direct response. 1.39. What is the ratio of the Total Labor Force (in %) in 1991 in East Asia (developing only) to that in Europe(developing only)?
Your answer should be very brief. 1.38. What is the ratio of the Total Labor Force (in %) in 1992 in East Asia (developing only) to that in Europe(developing only)?
Make the answer very short. 1.39. What is the ratio of the Total Labor Force (in %) in 1993 in East Asia (developing only) to that in Europe(developing only)?
Offer a very short reply. 1.43. What is the ratio of the Total Labor Force (in %) of 1990 in Euro area to that in Europe(all income levels)?
Keep it short and to the point. 0.85. What is the ratio of the Total Labor Force (in %) of 1991 in Euro area to that in Europe(all income levels)?
Offer a very short reply. 0.87. What is the ratio of the Total Labor Force (in %) of 1992 in Euro area to that in Europe(all income levels)?
Make the answer very short. 0.88. What is the ratio of the Total Labor Force (in %) of 1993 in Euro area to that in Europe(all income levels)?
Your answer should be very brief. 0.89. What is the ratio of the Total Labor Force (in %) in 1990 in Euro area to that in Europe(developing only)?
Provide a short and direct response. 0.83. What is the ratio of the Total Labor Force (in %) of 1991 in Euro area to that in Europe(developing only)?
Ensure brevity in your answer.  0.86. What is the ratio of the Total Labor Force (in %) in 1992 in Euro area to that in Europe(developing only)?
Make the answer very short. 0.87. What is the ratio of the Total Labor Force (in %) of 1993 in Euro area to that in Europe(developing only)?
Provide a short and direct response. 0.89. What is the ratio of the Total Labor Force (in %) of 1990 in Europe(all income levels) to that in Europe(developing only)?
Offer a very short reply. 0.98. What is the difference between the highest and the second highest Total Labor Force (in %) in 1990?
Ensure brevity in your answer.  2.52. What is the difference between the highest and the second highest Total Labor Force (in %) in 1991?
Your response must be concise. 2.43. What is the difference between the highest and the second highest Total Labor Force (in %) in 1992?
Make the answer very short. 2.37. What is the difference between the highest and the second highest Total Labor Force (in %) of 1993?
Provide a short and direct response. 2.38. What is the difference between the highest and the lowest Total Labor Force (in %) of 1990?
Your answer should be very brief. 27.64. What is the difference between the highest and the lowest Total Labor Force (in %) of 1991?
Offer a very short reply. 25.94. What is the difference between the highest and the lowest Total Labor Force (in %) of 1992?
Your response must be concise. 25.87. What is the difference between the highest and the lowest Total Labor Force (in %) in 1993?
Keep it short and to the point. 25.73. 